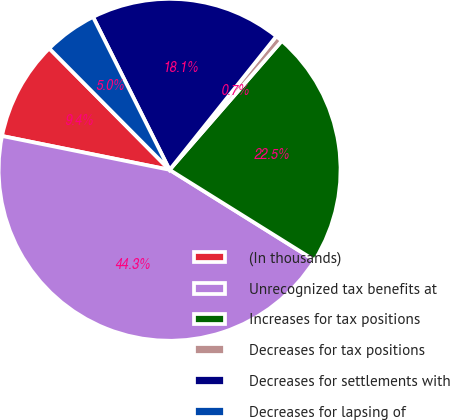<chart> <loc_0><loc_0><loc_500><loc_500><pie_chart><fcel>(In thousands)<fcel>Unrecognized tax benefits at<fcel>Increases for tax positions<fcel>Decreases for tax positions<fcel>Decreases for settlements with<fcel>Decreases for lapsing of<nl><fcel>9.4%<fcel>44.29%<fcel>22.48%<fcel>0.67%<fcel>18.12%<fcel>5.04%<nl></chart> 